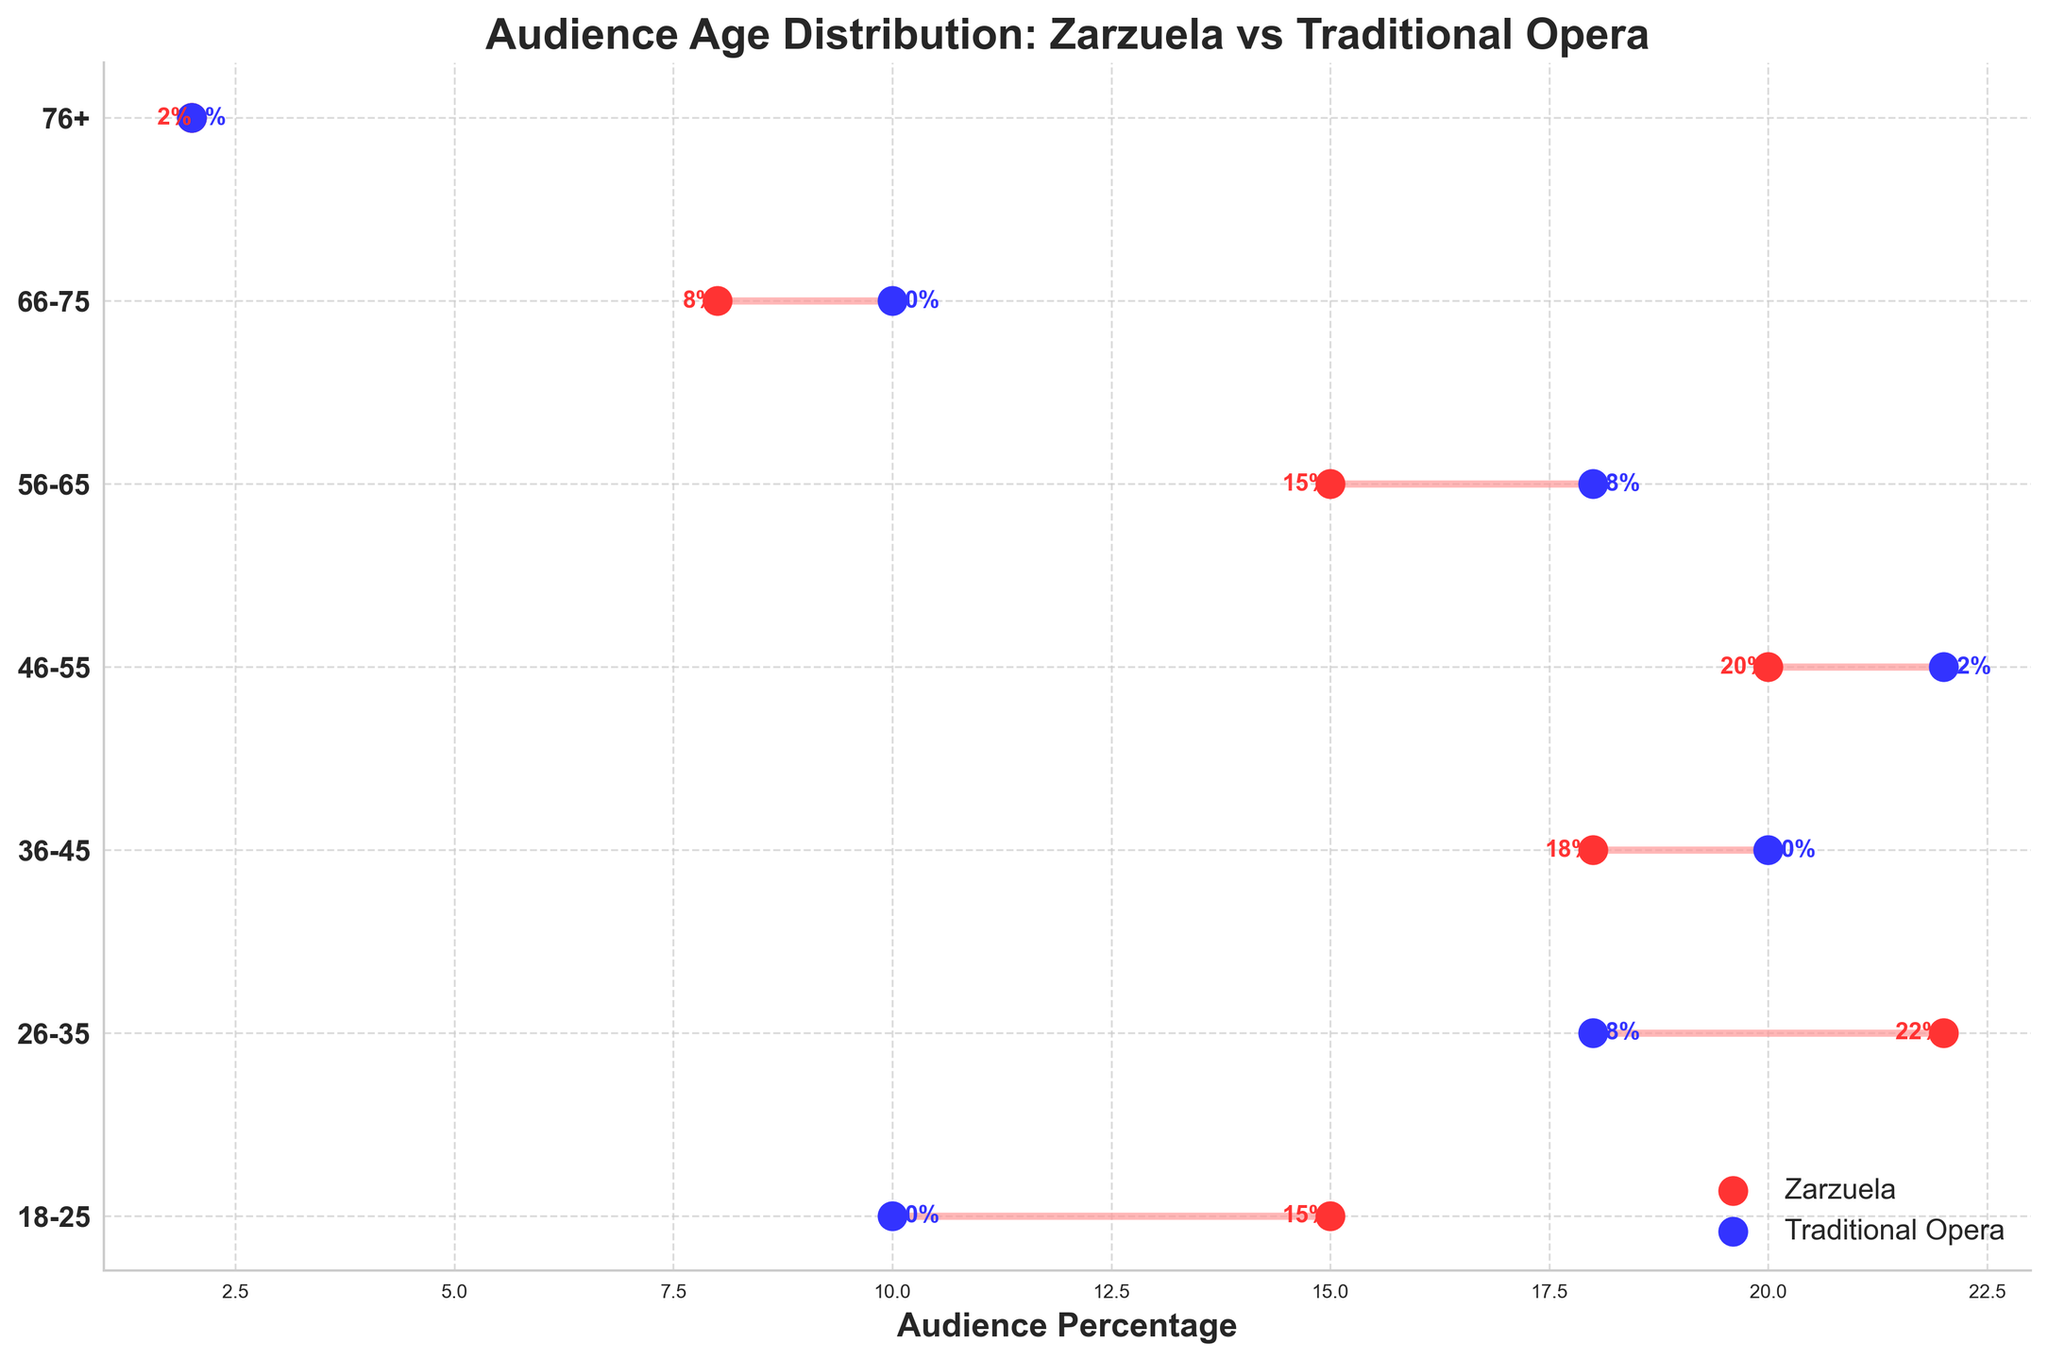What is the title of the figure? The title is typically located at the top of the figure, summarizing its content. In this case, the title clearly mentions the main focus of the chart.
Answer: Audience Age Distribution: Zarzuela vs Traditional Opera Which age group has the highest percentage of Zarzuela audience? By scanning each of the points for Zarzuela (red dots) on the x-axis, we can identify the largest percentage value.
Answer: 26-35 How many age groups are there in the dataset? To find the number of age groups, we count the number of horizontal positions (y-ticks) on the chart.
Answer: 7 What is the percentage difference between Zarzuela and Traditional Opera audiences for the age group 46-55? The percentage for Zarzuela is 20%, and for Traditional Opera, it is 22%. The difference is calculated by subtracting the smaller value from the larger one.
Answer: 2% Which audience age group shows no difference between Zarzuela and Traditional Opera? By examining each pair of points on the plot, we notice that for the 76+ age group, both Zarzuela and Traditional Opera have the same percentage.
Answer: 76+ What age group has a higher percentage of Traditional Opera audience than Zarzuela in all other groups? By comparing both sets of points across all age groups, the age group 56-65 has a higher percentage for Traditional Opera (18%) compared to Zarzuela (15%) consistently.
Answer: 56-65 What is the average percentage of Zarzuela audience across all age groups? Summing the percentage values for Zarzuela and dividing by the number of age groups gives:
(15 + 22 + 18 + 20 + 15 + 8 + 2) / 7 = 100 / 7
Answer: ~14.29% Which age group has the closest audience distribution between Zarzuela and Traditional Opera? By checking the distances between the paired points, the age group 76+ has both Zarzuela and Traditional Opera at 2%.
Answer: 76+ Are there any age groups where the percentage of Zarzuela audience is less than that of the Traditional Opera audience? We compare all pairs of red (Zarzuela) and blue (Traditional Opera) points. The 36-45, 46-55, and 56-65 groups show this trend.
Answer: Yes, 3 groups (36-45, 46-55, 56-65) For which age group is the percentage of Zarzuela audience exactly equal to that of the Traditional Opera audience? Observing the percentage values on the plot reveals that the 76+ age group has an equal percentage for both Zarzuela and Traditional Opera.
Answer: 76+ 